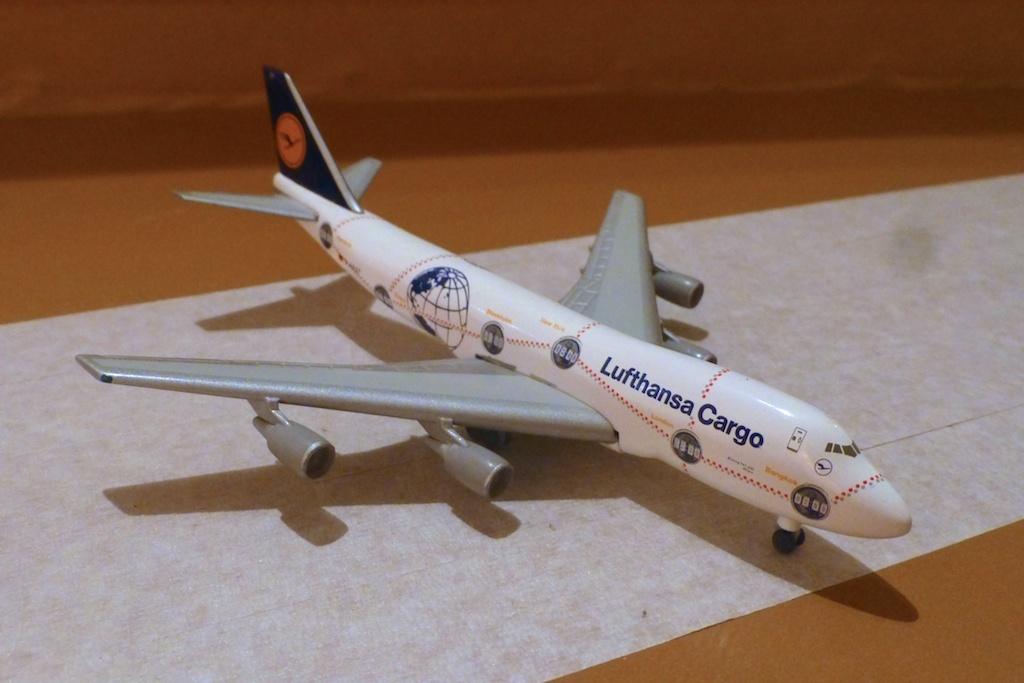What kind of airline is this?
Your answer should be very brief. Lufthansa cargo. 